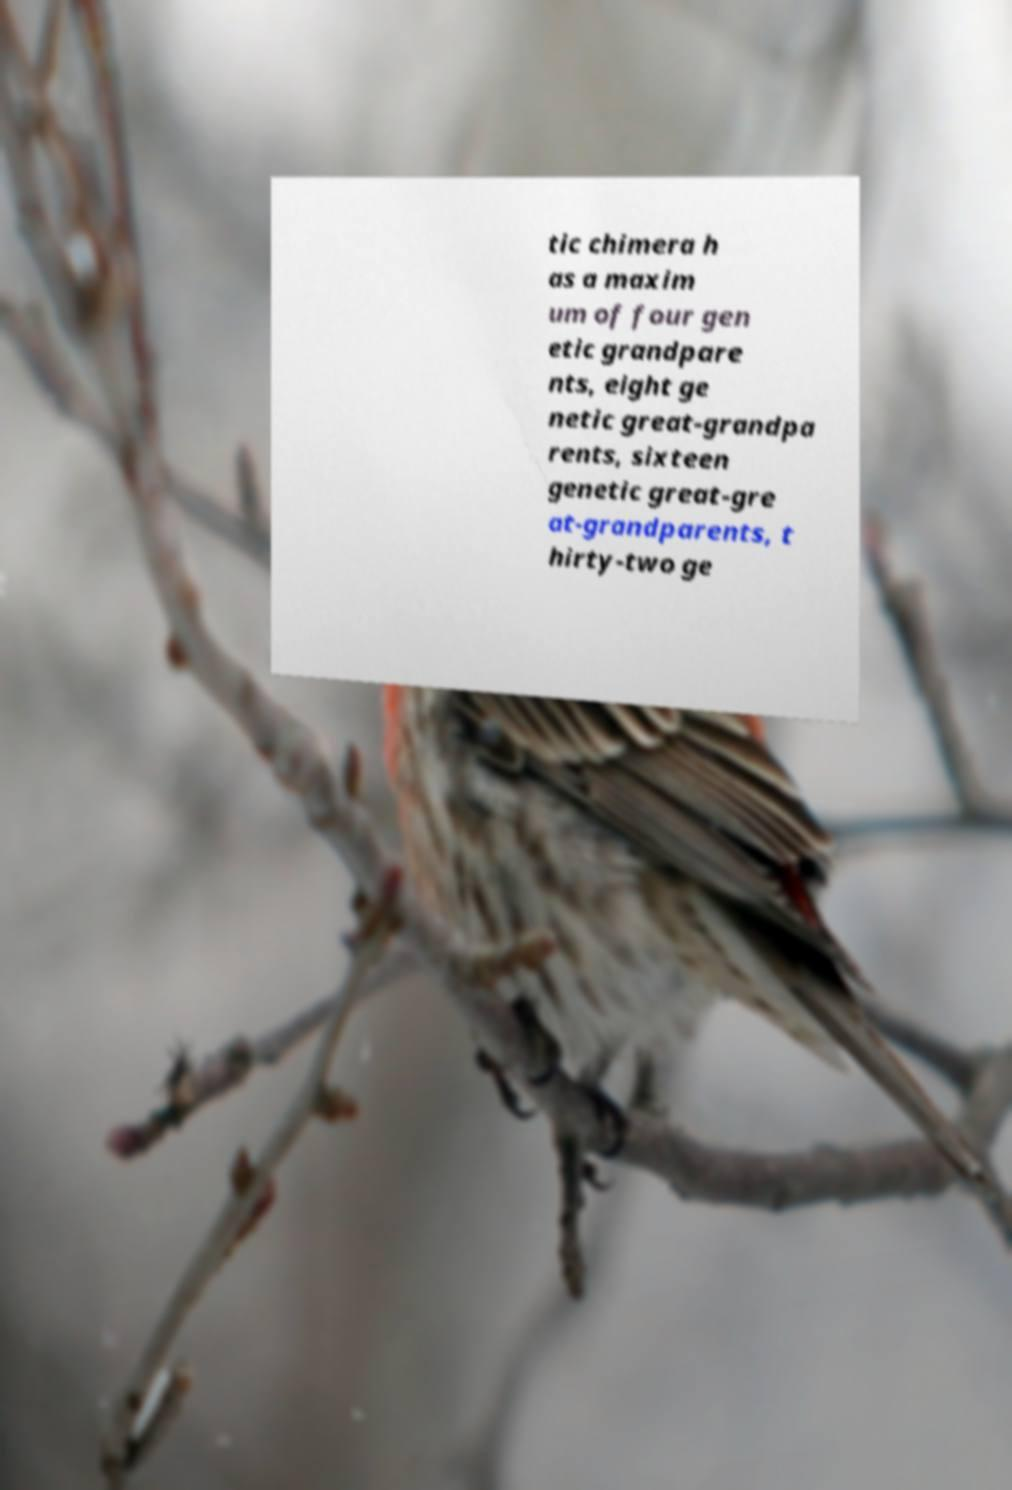What messages or text are displayed in this image? I need them in a readable, typed format. tic chimera h as a maxim um of four gen etic grandpare nts, eight ge netic great-grandpa rents, sixteen genetic great-gre at-grandparents, t hirty-two ge 